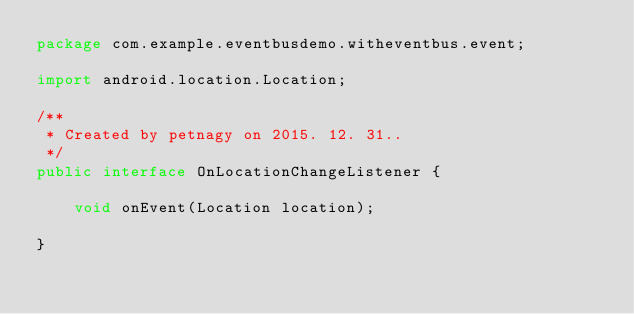Convert code to text. <code><loc_0><loc_0><loc_500><loc_500><_Java_>package com.example.eventbusdemo.witheventbus.event;

import android.location.Location;

/**
 * Created by petnagy on 2015. 12. 31..
 */
public interface OnLocationChangeListener {

    void onEvent(Location location);

}
</code> 